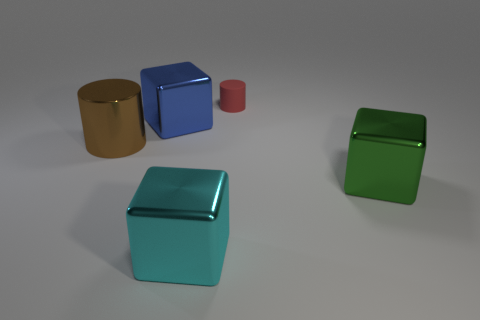Subtract all cyan cylinders. Subtract all blue blocks. How many cylinders are left? 2 Add 5 red metal cubes. How many objects exist? 10 Subtract all blocks. How many objects are left? 2 Add 1 large blue blocks. How many large blue blocks exist? 2 Subtract 0 gray cubes. How many objects are left? 5 Subtract all large green metallic objects. Subtract all cyan shiny blocks. How many objects are left? 3 Add 5 matte cylinders. How many matte cylinders are left? 6 